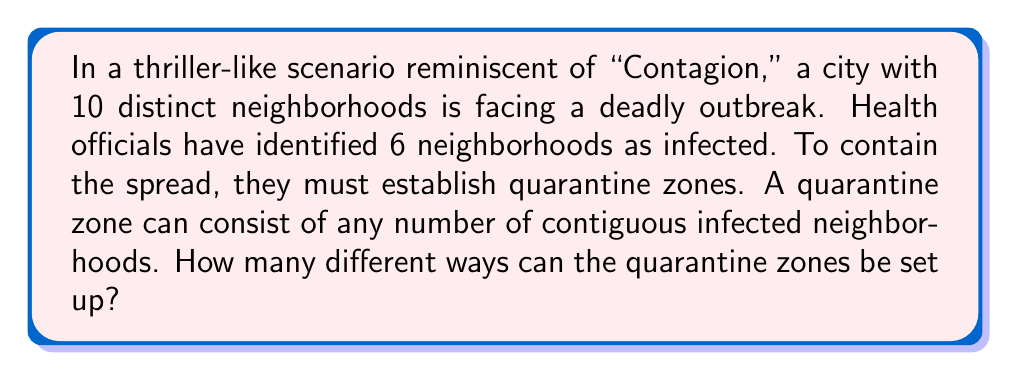Can you answer this question? Let's approach this step-by-step:

1) First, we need to understand what the question is asking. We're looking for the number of ways to partition 6 infected neighborhoods into contiguous groups.

2) This problem is equivalent to finding the number of ways to insert dividers between the infected neighborhoods. We can have anywhere from 0 to 5 dividers.

3) With 6 infected neighborhoods, there are 5 spaces between them where we can place dividers. Each space can either have a divider or not.

4) This is a classic application of the subset selection problem. We are essentially selecting a subset of spaces (from 0 to 5) to place dividers.

5) The number of ways to select a subset from a set of n elements is given by $2^n$.

6) In this case, n = 5 (the number of spaces between infected neighborhoods).

7) Therefore, the total number of ways to set up the quarantine zones is:

   $$2^5 = 32$$

This accounts for all possible configurations, from one large quarantine zone (no dividers) to six individual quarantine zones (dividers in all 5 spaces).
Answer: $32$ 